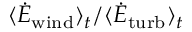<formula> <loc_0><loc_0><loc_500><loc_500>\langle \dot { E } _ { w i n d } \rangle _ { t } / \langle \dot { E } _ { t u r b } \rangle _ { t }</formula> 